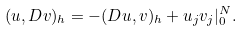Convert formula to latex. <formula><loc_0><loc_0><loc_500><loc_500>( u , D v ) _ { h } = - ( D u , v ) _ { h } + u _ { j } v _ { j } | ^ { N } _ { 0 } .</formula> 